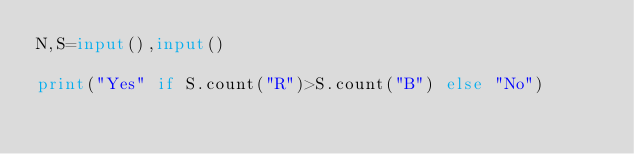<code> <loc_0><loc_0><loc_500><loc_500><_Python_>N,S=input(),input()

print("Yes" if S.count("R")>S.count("B") else "No")</code> 